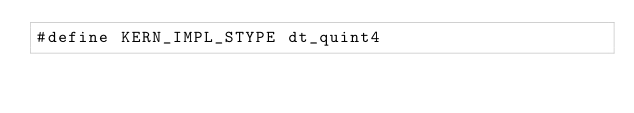<code> <loc_0><loc_0><loc_500><loc_500><_Cuda_>#define KERN_IMPL_STYPE dt_quint4</code> 